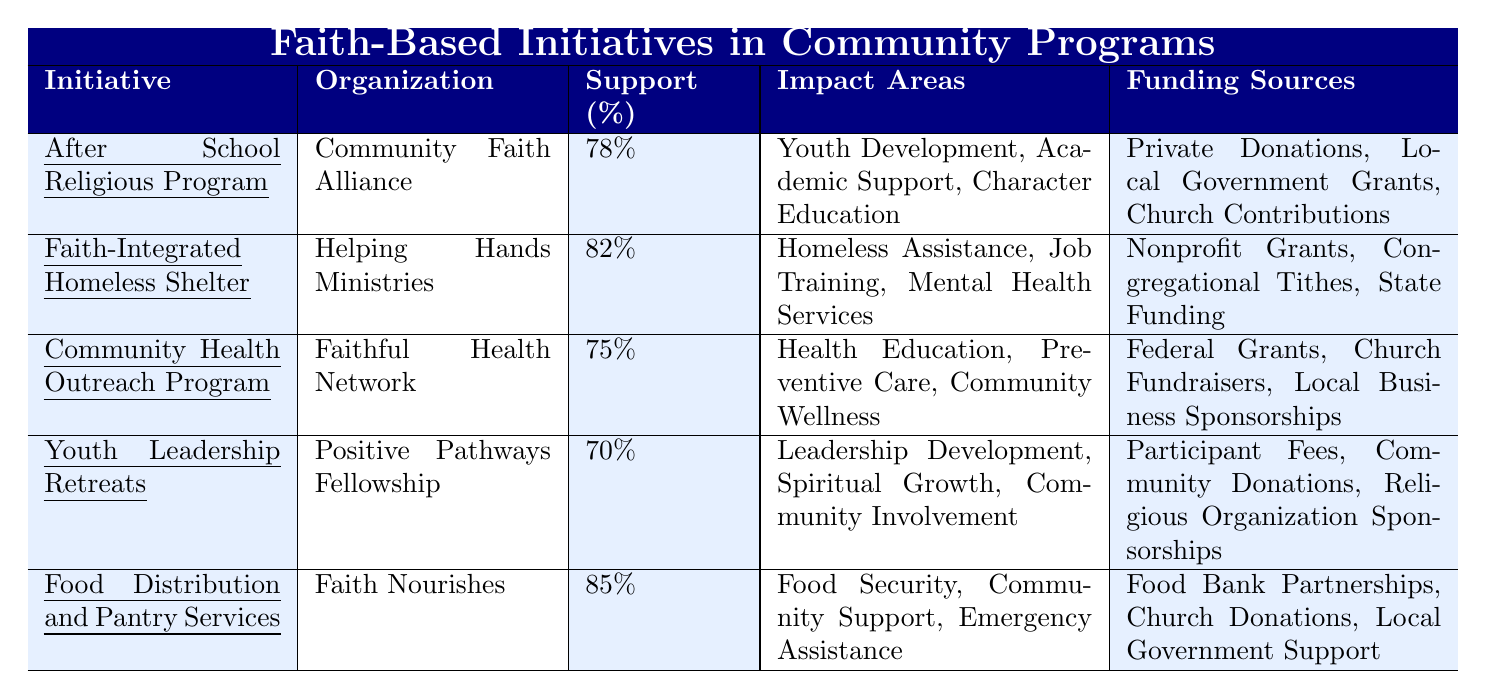What is the support percentage for the "Food Distribution and Pantry Services" initiative? According to the table, the support percentage for the "Food Distribution and Pantry Services" initiative is clearly listed as 85%.
Answer: 85% Which organization runs the "After School Religious Program"? The table indicates that the "After School Religious Program" is organized by the "Community Faith Alliance."
Answer: Community Faith Alliance What are the impact areas of the "Faith-Integrated Homeless Shelter"? The table provides the impact areas for the "Faith-Integrated Homeless Shelter" as Homeless Assistance, Job Training, and Mental Health Services.
Answer: Homeless Assistance, Job Training, Mental Health Services What is the average support percentage of all initiatives listed in the table? The support percentages are 78%, 82%, 75%, 70%, and 85%. Adding these gives 390%, and dividing by 5 (the number of initiatives) gives an average of 78%.
Answer: 78% Is the support percentage for the "Community Health Outreach Program" higher than that for "Youth Leadership Retreats"? The support percentage for "Community Health Outreach Program" is 75%, and for "Youth Leadership Retreats," it is 70%. Since 75% is greater than 70%, the answer is yes.
Answer: Yes How many initiatives have a support percentage of 80% or higher? The initiatives with support percentages of 80% or higher are "Faith-Integrated Homeless Shelter" (82%) and "Food Distribution and Pantry Services" (85%). This totals 2 initiatives.
Answer: 2 Which initiative has the lowest support percentage? The lowest support percentage listed in the table is for the "Youth Leadership Retreats," at 70%.
Answer: Youth Leadership Retreats What is the difference in support percentage between the "Faith-Integrated Homeless Shelter" and the "Community Health Outreach Program"? The support percentage for the "Faith-Integrated Homeless Shelter" is 82%, and for the "Community Health Outreach Program" it is 75%. The difference is 82% - 75% = 7%.
Answer: 7% Are the funding sources for the "Food Distribution and Pantry Services" varied compared to the "Youth Leadership Retreats"? The "Food Distribution and Pantry Services" lists Food Bank Partnerships, Church Donations, and Local Government Support, while the "Youth Leadership Retreats" lists Participant Fees, Community Donations, and Religious Organization Sponsorships, indicating both have varied funding sources.
Answer: Yes Which organization supports initiatives that impact "Food Security"? The "Food Distribution and Pantry Services," supported by "Faith Nourishes," specifically addresses Food Security, as indicated in the impact areas column of the table.
Answer: Faith Nourishes 